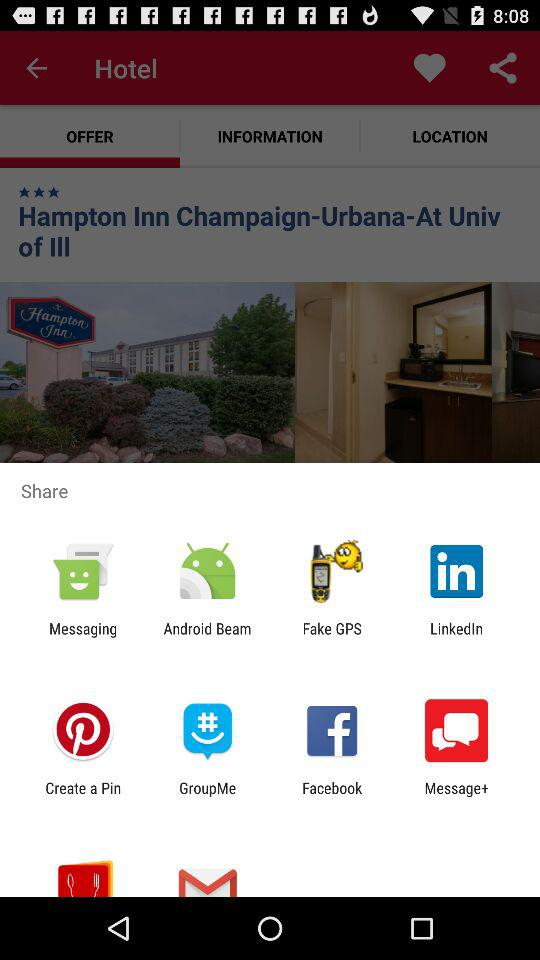Through which applications and mediums can the content be shared? The content can be shared through "Messaging", "Android Beam", "Fake GPS", "LinkedIn", "Create a Pin", "GroupMe", "Facebook" and "Message+". 